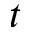Convert formula to latex. <formula><loc_0><loc_0><loc_500><loc_500>t</formula> 